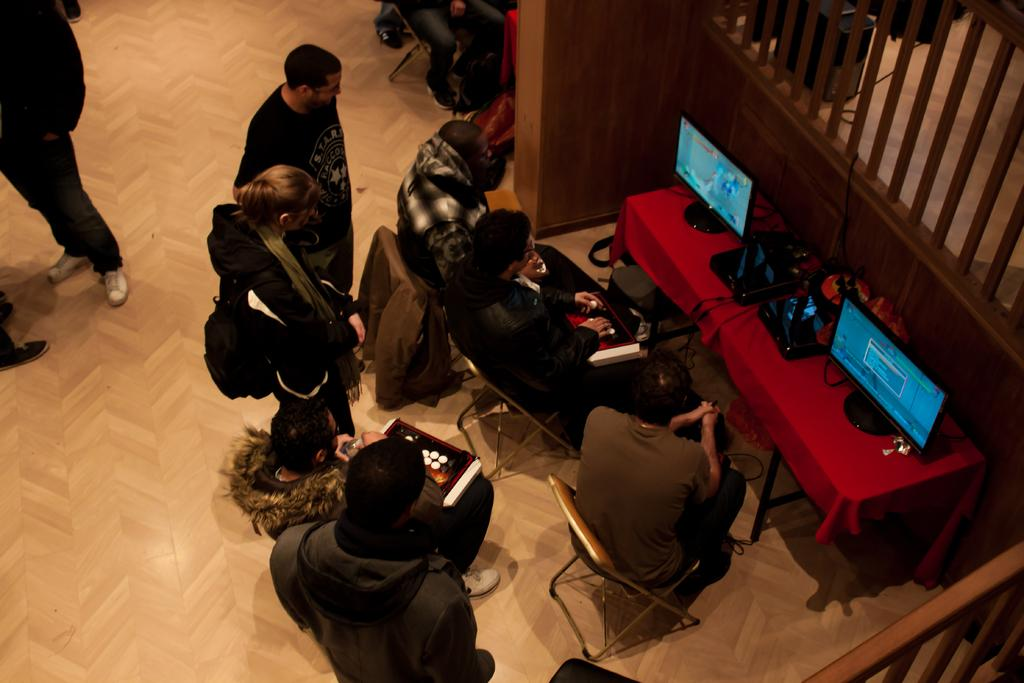How many persons are visible in the image? There are a few persons in the image. What objects can be seen on the table in the image? There are two computers on a table in the image. What type of skirt is the ladybug wearing in the image? There is no ladybug present in the image, and therefore no skirt can be observed. Is there any indication of a war happening in the image? There is no indication of a war happening in the image; it features a few persons and two computers on a table. 